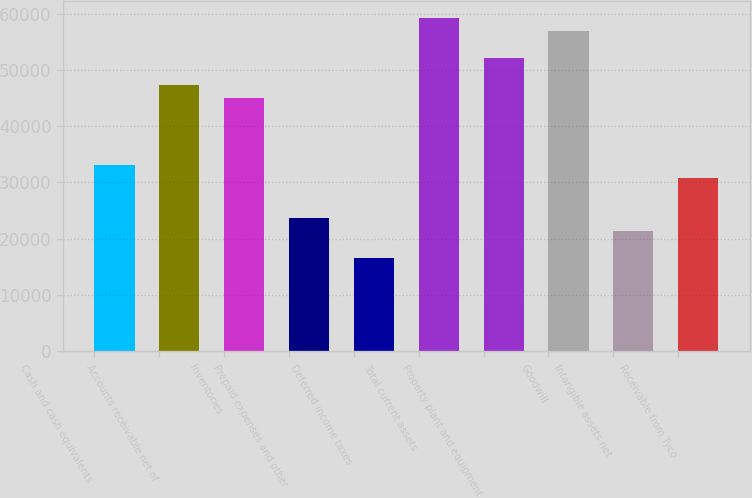Convert chart. <chart><loc_0><loc_0><loc_500><loc_500><bar_chart><fcel>Cash and cash equivalents<fcel>Accounts receivable net of<fcel>Inventories<fcel>Prepaid expenses and other<fcel>Deferred income taxes<fcel>Total current assets<fcel>Property plant and equipment<fcel>Goodwill<fcel>Intangible assets net<fcel>Receivable from Tyco<nl><fcel>33162.4<fcel>47374<fcel>45005.4<fcel>23688<fcel>16582.2<fcel>59217<fcel>52111.2<fcel>56848.4<fcel>21319.4<fcel>30793.8<nl></chart> 